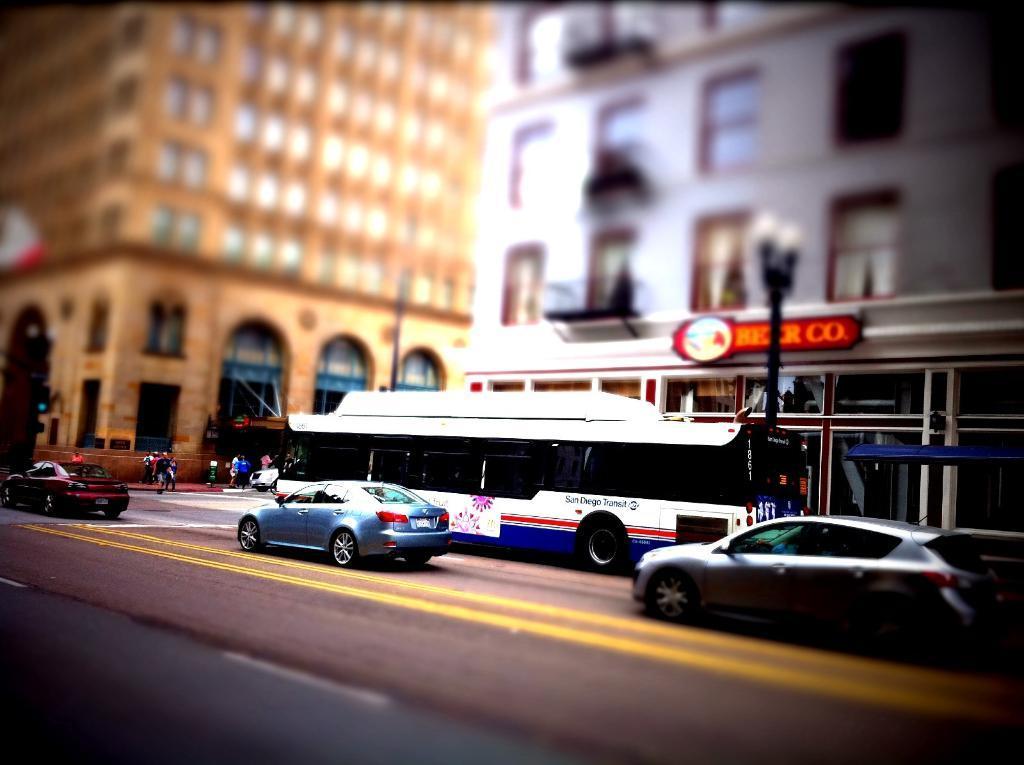Describe this image in one or two sentences. In this picture we can see few vehicles on the road, in the background we can find few buildings, poles, hoarding and group of people. 